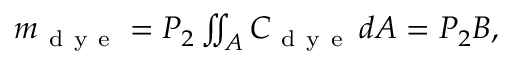Convert formula to latex. <formula><loc_0><loc_0><loc_500><loc_500>\begin{array} { r } { m _ { d y e } = P _ { 2 } \iint _ { A } C _ { d y e } \, d A = P _ { 2 } B , } \end{array}</formula> 